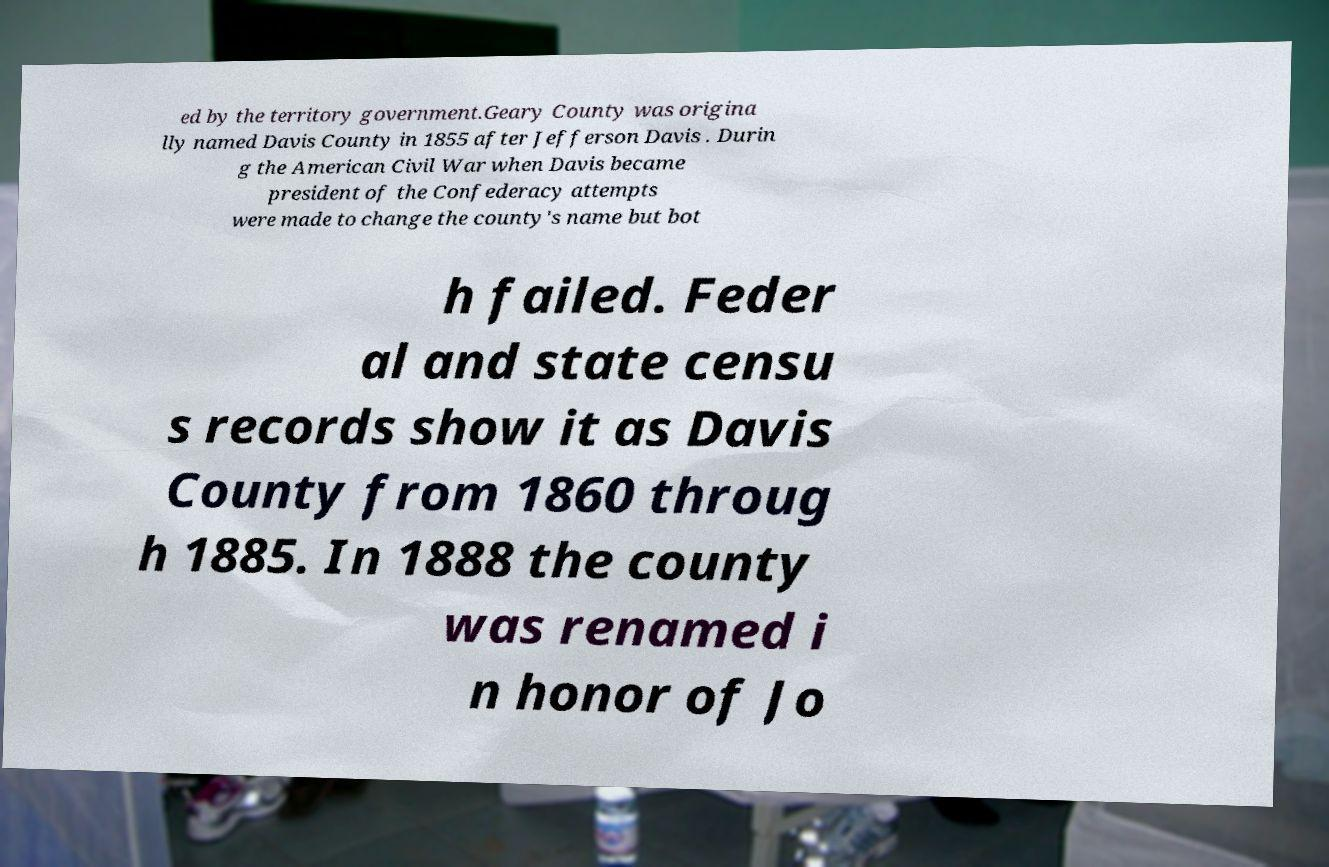Please identify and transcribe the text found in this image. ed by the territory government.Geary County was origina lly named Davis County in 1855 after Jefferson Davis . Durin g the American Civil War when Davis became president of the Confederacy attempts were made to change the county's name but bot h failed. Feder al and state censu s records show it as Davis County from 1860 throug h 1885. In 1888 the county was renamed i n honor of Jo 